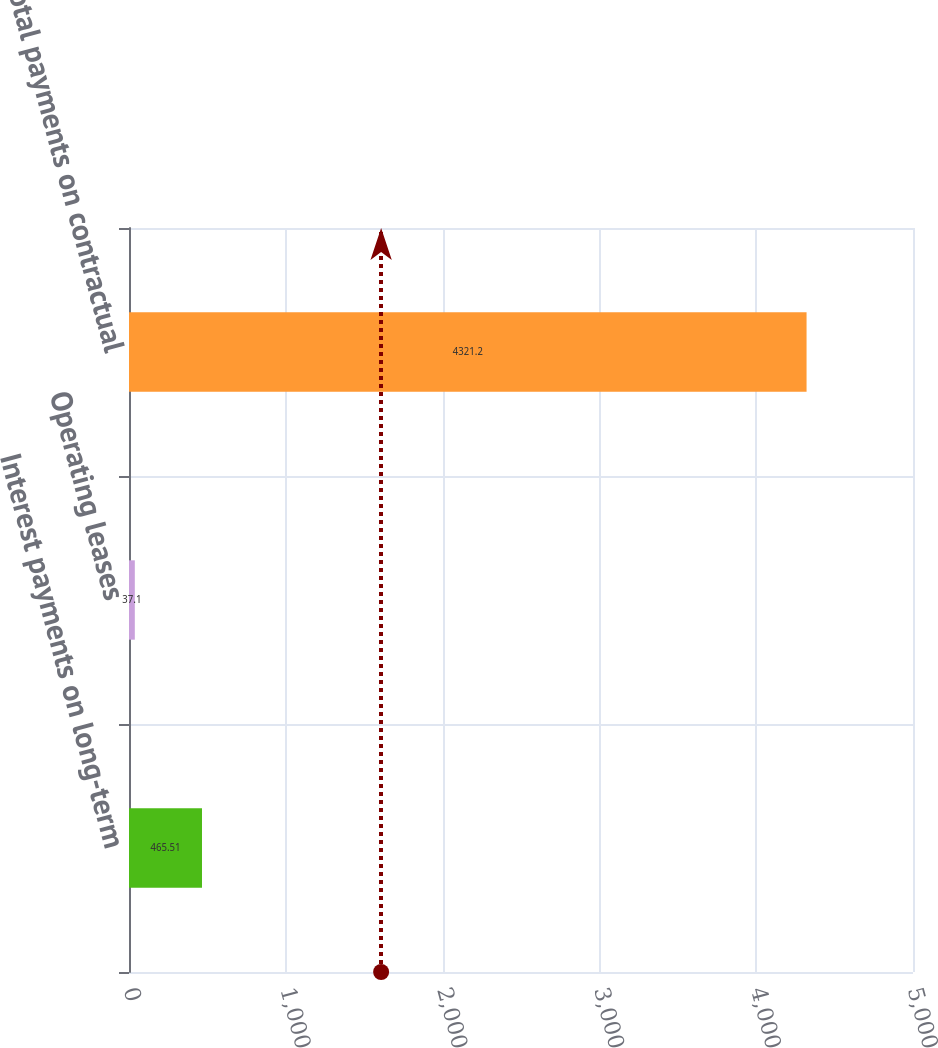Convert chart. <chart><loc_0><loc_0><loc_500><loc_500><bar_chart><fcel>Interest payments on long-term<fcel>Operating leases<fcel>Total payments on contractual<nl><fcel>465.51<fcel>37.1<fcel>4321.2<nl></chart> 